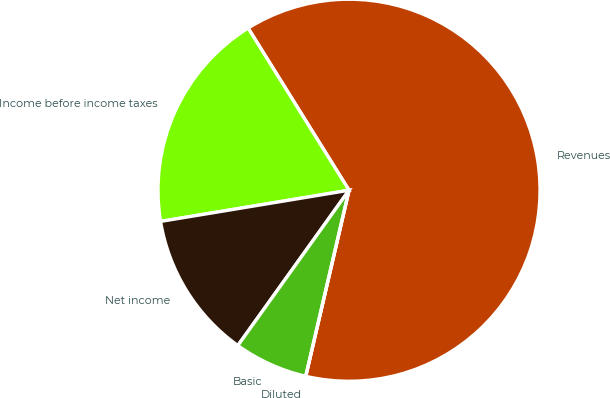Convert chart. <chart><loc_0><loc_0><loc_500><loc_500><pie_chart><fcel>Revenues<fcel>Income before income taxes<fcel>Net income<fcel>Basic<fcel>Diluted<nl><fcel>62.5%<fcel>18.75%<fcel>12.5%<fcel>6.25%<fcel>0.0%<nl></chart> 